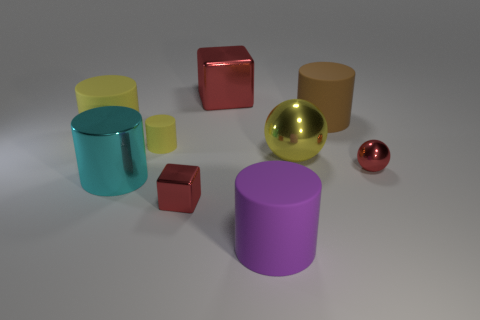Is the small matte object the same color as the big sphere?
Your answer should be compact. Yes. How many green rubber blocks are there?
Your answer should be very brief. 0. What number of tiny things are yellow shiny spheres or red matte cylinders?
Offer a terse response. 0. The shiny cube that is in front of the small thing that is on the right side of the red block behind the cyan metallic cylinder is what color?
Make the answer very short. Red. What number of other objects are there of the same color as the big ball?
Offer a very short reply. 2. What number of shiny things are either red spheres or yellow cylinders?
Your answer should be very brief. 1. Do the object that is on the right side of the large brown cylinder and the block that is right of the tiny red cube have the same color?
Offer a very short reply. Yes. There is another metallic object that is the same shape as the small yellow object; what is its size?
Your response must be concise. Large. Are there more brown things to the right of the big yellow matte cylinder than small gray metallic cubes?
Provide a short and direct response. Yes. Do the red block behind the big cyan metallic cylinder and the big purple cylinder have the same material?
Make the answer very short. No. 